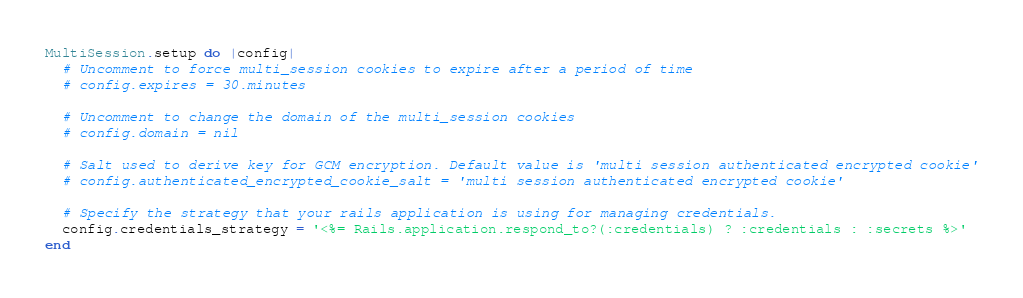<code> <loc_0><loc_0><loc_500><loc_500><_Ruby_>MultiSession.setup do |config|
  # Uncomment to force multi_session cookies to expire after a period of time
  # config.expires = 30.minutes

  # Uncomment to change the domain of the multi_session cookies
  # config.domain = nil

  # Salt used to derive key for GCM encryption. Default value is 'multi session authenticated encrypted cookie'
  # config.authenticated_encrypted_cookie_salt = 'multi session authenticated encrypted cookie'

  # Specify the strategy that your rails application is using for managing credentials.
  config.credentials_strategy = '<%= Rails.application.respond_to?(:credentials) ? :credentials : :secrets %>'
end
</code> 